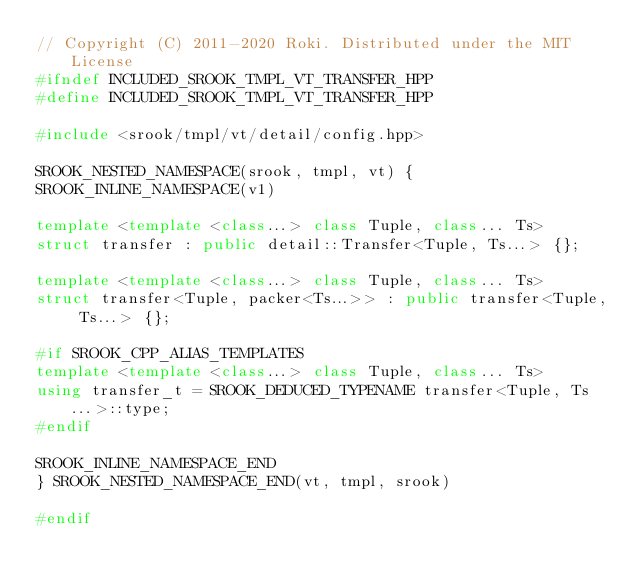<code> <loc_0><loc_0><loc_500><loc_500><_C++_>// Copyright (C) 2011-2020 Roki. Distributed under the MIT License
#ifndef INCLUDED_SROOK_TMPL_VT_TRANSFER_HPP
#define INCLUDED_SROOK_TMPL_VT_TRANSFER_HPP

#include <srook/tmpl/vt/detail/config.hpp>

SROOK_NESTED_NAMESPACE(srook, tmpl, vt) {
SROOK_INLINE_NAMESPACE(v1)

template <template <class...> class Tuple, class... Ts>
struct transfer : public detail::Transfer<Tuple, Ts...> {};

template <template <class...> class Tuple, class... Ts>
struct transfer<Tuple, packer<Ts...>> : public transfer<Tuple, Ts...> {};

#if SROOK_CPP_ALIAS_TEMPLATES
template <template <class...> class Tuple, class... Ts>
using transfer_t = SROOK_DEDUCED_TYPENAME transfer<Tuple, Ts...>::type;
#endif

SROOK_INLINE_NAMESPACE_END
} SROOK_NESTED_NAMESPACE_END(vt, tmpl, srook)

#endif
</code> 